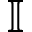Convert formula to latex. <formula><loc_0><loc_0><loc_500><loc_500>\mathbb { I }</formula> 